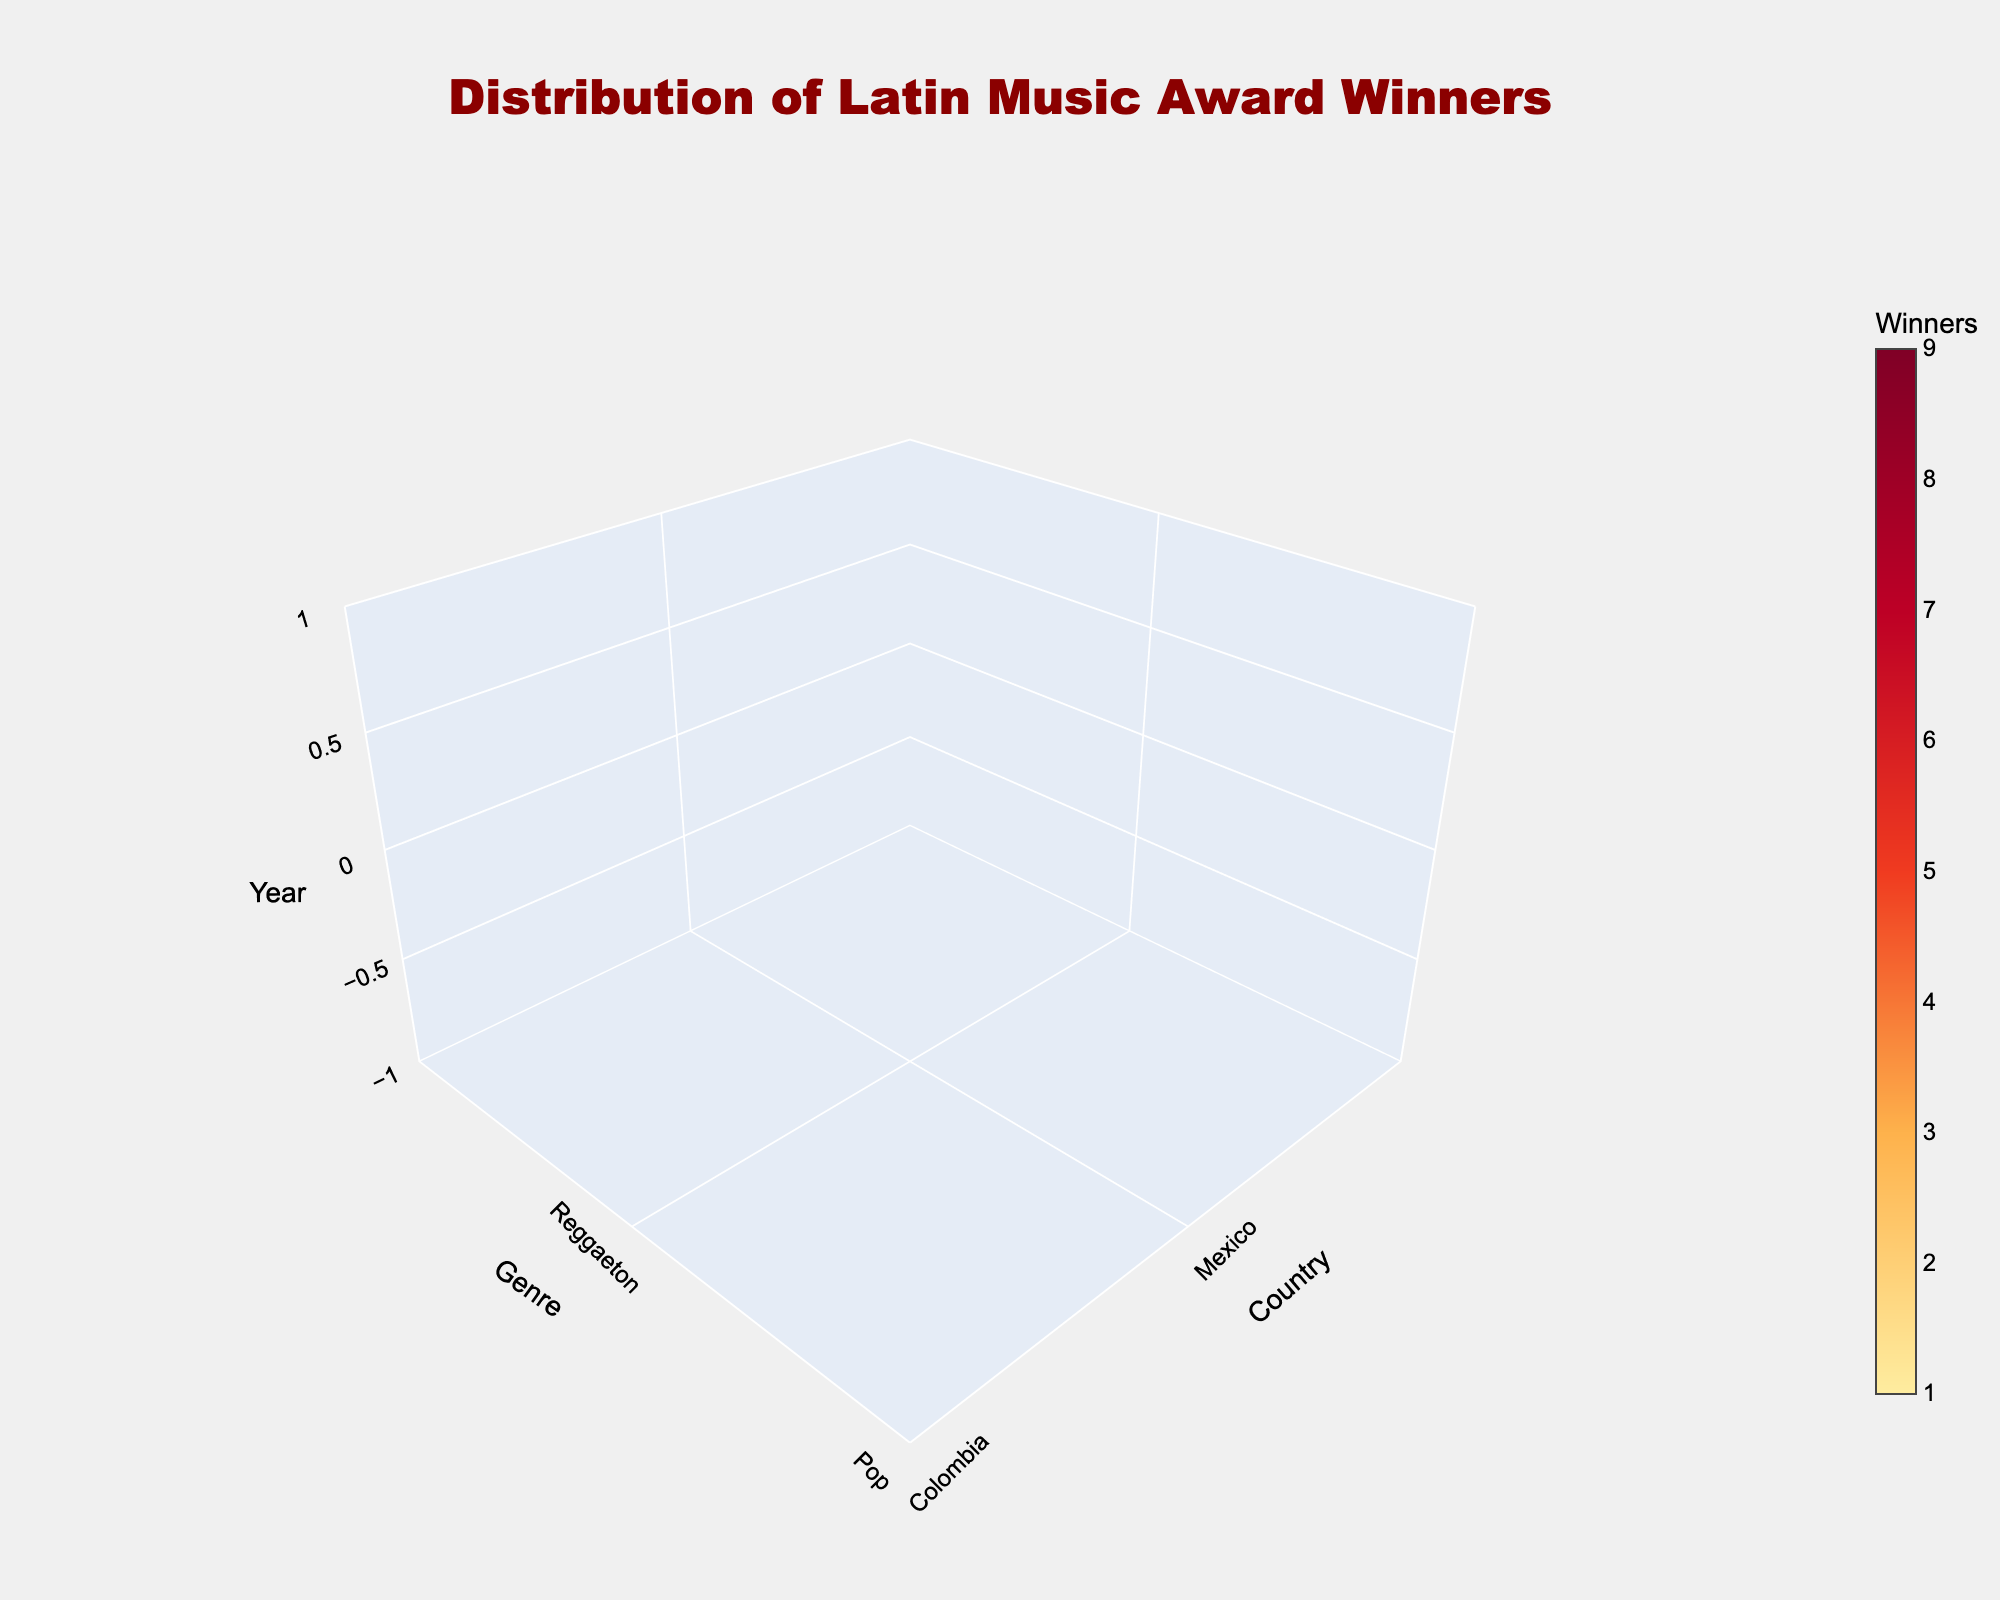what is the title of the 3D plot? The title can be seen at the top center of the figure. It is styled in a large font and dark red color.
Answer: Distribution of Latin Music Award Winners Which country and genre combination had the highest number of winners in the year 2020? Look at the 2020 plane in the 3D plot, then find the combination with the darkest color (highest value) in that plane.
Answer: Puerto Rico, Reggaeton How many countries are represented in the 3D volume plot? Count the unique values on the x-axis labeled 'Country'.
Answer: Six What genre in Mexico had the highest number of winners in 2010? Locate Mexico on the x-axis, 2010 on the z-axis and check within that plane for the genre with the highest value (darkest color).
Answer: Regional Mexican From 1995 to 2020, which country shows the most consistent winning counts across different genres? Assess the consistency of color intensity along planes for each country.
Answer: Colombia How does the distribution of genres in Puerto Rico change over the years? Track the variation in color (value of winners) across different genres and years for Puerto Rico.
Answer: Shift from Salsa and Reggaeton dominance to increasing prominence of Reggaeton and Trap Which country contributed the most winners in the Reggaeton genre over all the years? Summarize the winners' values for Reggaeton across all years for each country and compare.
Answer: Puerto Rico is there any genre that appeared only once in a particular year? Check for any genres with less frequent appearances across all planes.
Answer: Yes, Bachata in 2015 What color indicates the highest number of winners in the color scale used in the plot? Refer to the color bar which shows the gradient corresponding to numbers of winners.
Answer: Darkest shade of red (close to black) In which decade did Mexico win more awards in the Pop genre? Compare the colors (intensity) on the 'Pop' planes for Mexico across 1990s, 2000s, and 2010s.
Answer: 2010s 